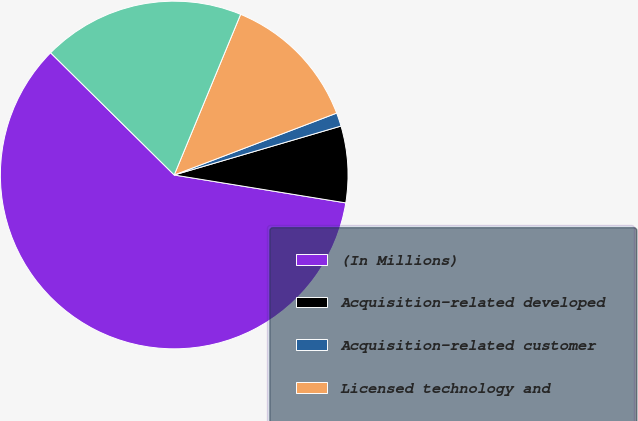Convert chart to OTSL. <chart><loc_0><loc_0><loc_500><loc_500><pie_chart><fcel>(In Millions)<fcel>Acquisition-related developed<fcel>Acquisition-related customer<fcel>Licensed technology and<fcel>Total future amortization<nl><fcel>59.85%<fcel>7.11%<fcel>1.25%<fcel>12.97%<fcel>18.83%<nl></chart> 